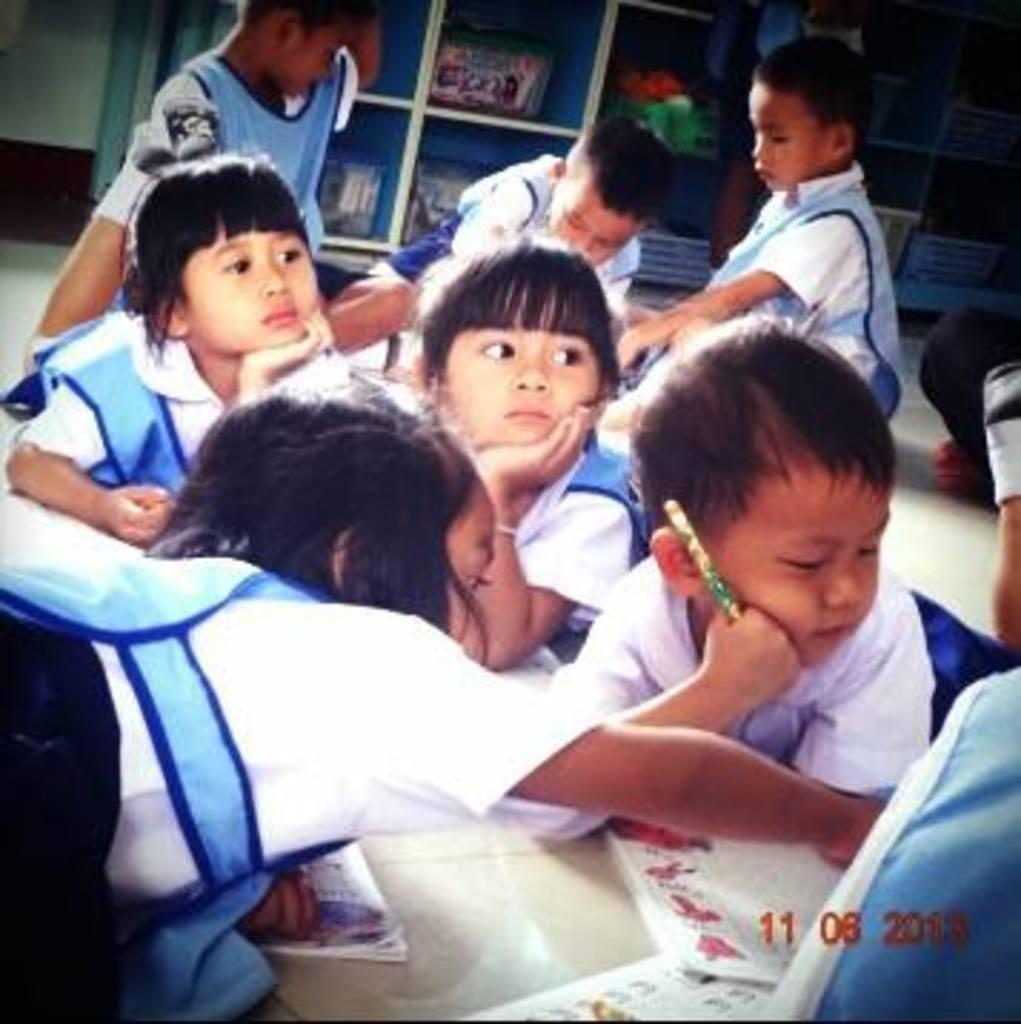Who is present in the image? There are kids in the image. What are the kids wearing? The kids are wearing white and blue color dresses. What can be seen in the background of the image? There are objects in the racks in the background of the image. How many clovers can be seen in the image? There are no clovers present in the image. What is the amount of love displayed in the image? The image does not depict love or any emotions; it simply shows kids wearing white and blue dresses with objects in the racks in the background. 